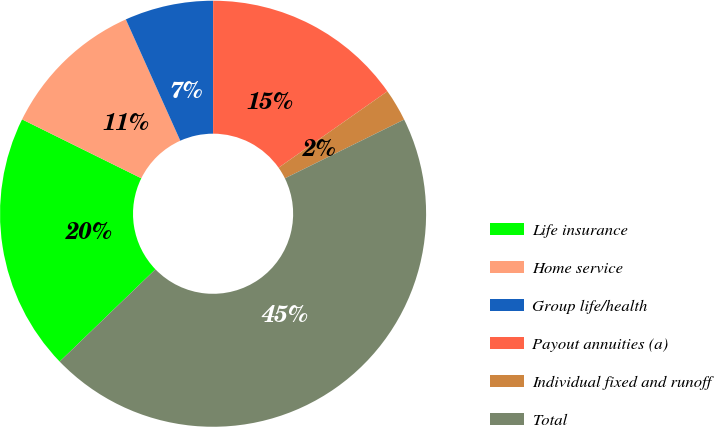<chart> <loc_0><loc_0><loc_500><loc_500><pie_chart><fcel>Life insurance<fcel>Home service<fcel>Group life/health<fcel>Payout annuities (a)<fcel>Individual fixed and runoff<fcel>Total<nl><fcel>19.51%<fcel>10.98%<fcel>6.72%<fcel>15.25%<fcel>2.46%<fcel>45.08%<nl></chart> 